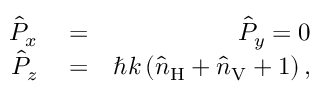Convert formula to latex. <formula><loc_0><loc_0><loc_500><loc_500>\begin{array} { r l r } { \hat { P } _ { x } } & = } & { \hat { P } _ { y } = 0 } \\ { \hat { P } _ { z } } & = } & { \hbar { k } \left ( \hat { n } _ { H } + \hat { n } _ { V } + 1 \right ) , } \end{array}</formula> 